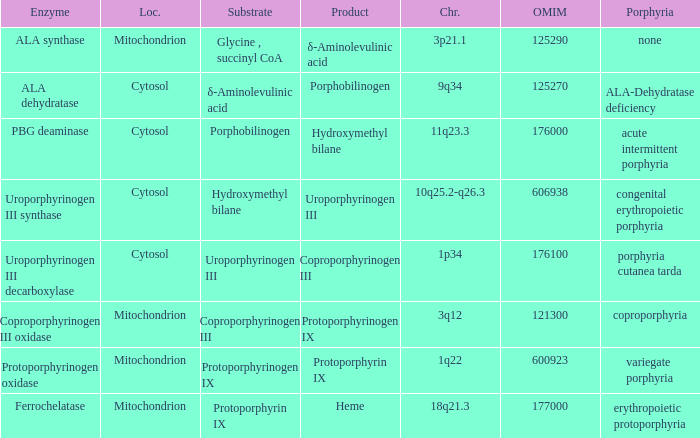What is the location of the enzyme Uroporphyrinogen iii Synthase? Cytosol. 